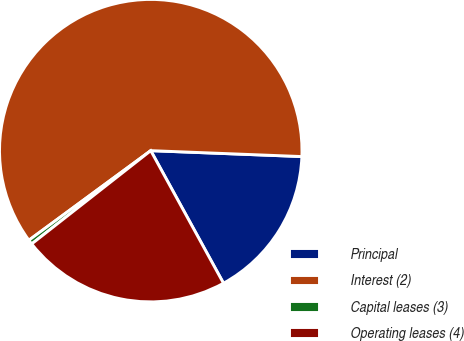Convert chart to OTSL. <chart><loc_0><loc_0><loc_500><loc_500><pie_chart><fcel>Principal<fcel>Interest (2)<fcel>Capital leases (3)<fcel>Operating leases (4)<nl><fcel>16.39%<fcel>60.71%<fcel>0.49%<fcel>22.41%<nl></chart> 